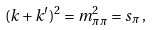<formula> <loc_0><loc_0><loc_500><loc_500>( k + k ^ { \prime } ) ^ { 2 } = m _ { \pi \pi } ^ { 2 } = s _ { \pi } \, ,</formula> 